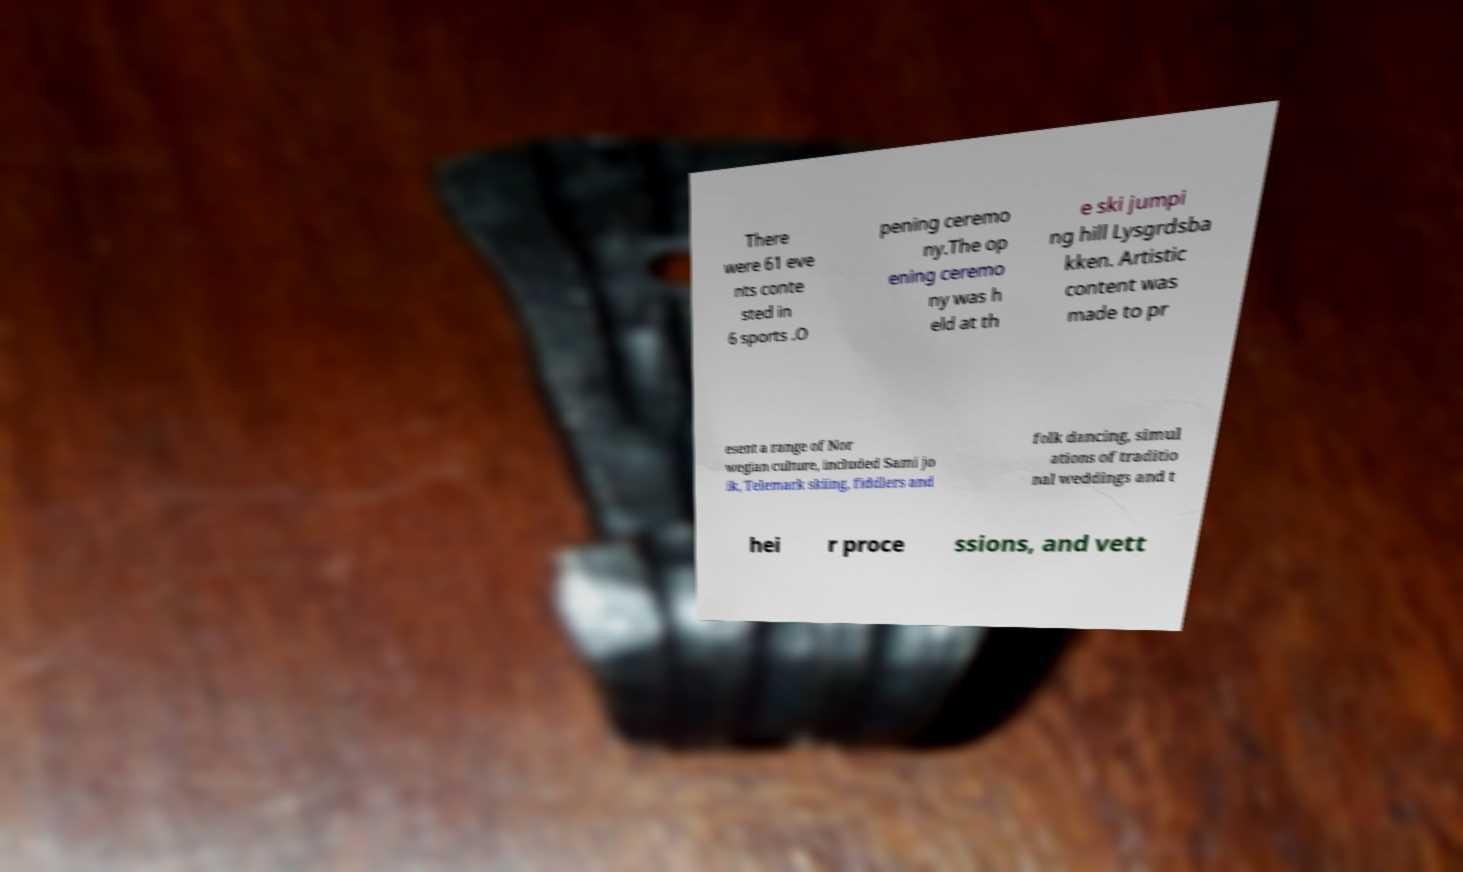Can you read and provide the text displayed in the image?This photo seems to have some interesting text. Can you extract and type it out for me? There were 61 eve nts conte sted in 6 sports .O pening ceremo ny.The op ening ceremo ny was h eld at th e ski jumpi ng hill Lysgrdsba kken. Artistic content was made to pr esent a range of Nor wegian culture, included Sami jo ik, Telemark skiing, fiddlers and folk dancing, simul ations of traditio nal weddings and t hei r proce ssions, and vett 